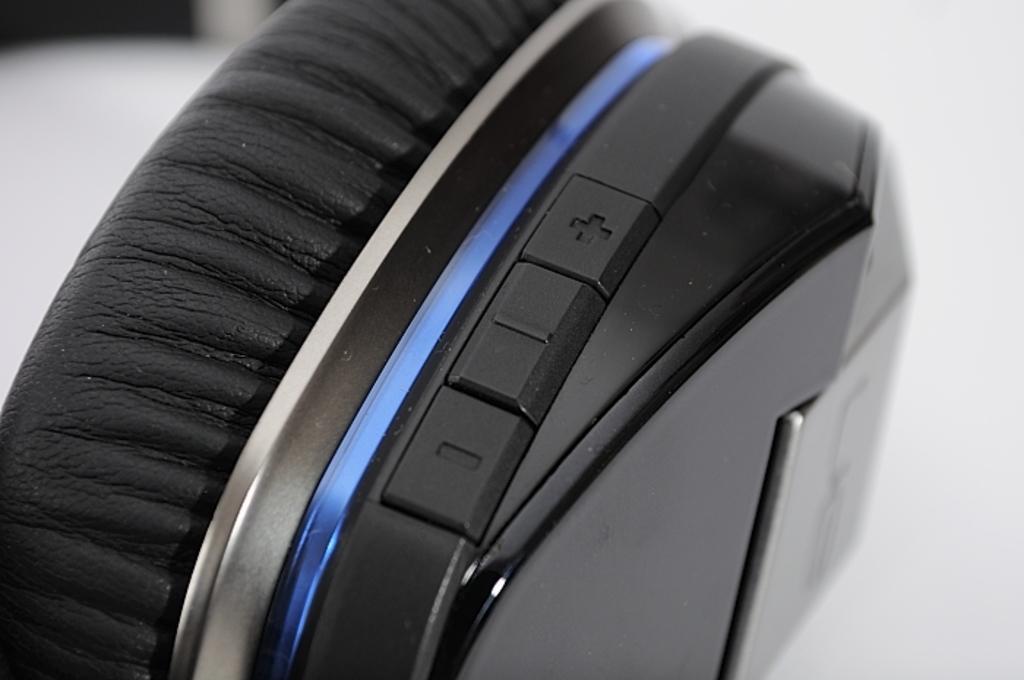How would you summarize this image in a sentence or two? In this given picture, I can see a headphone. 